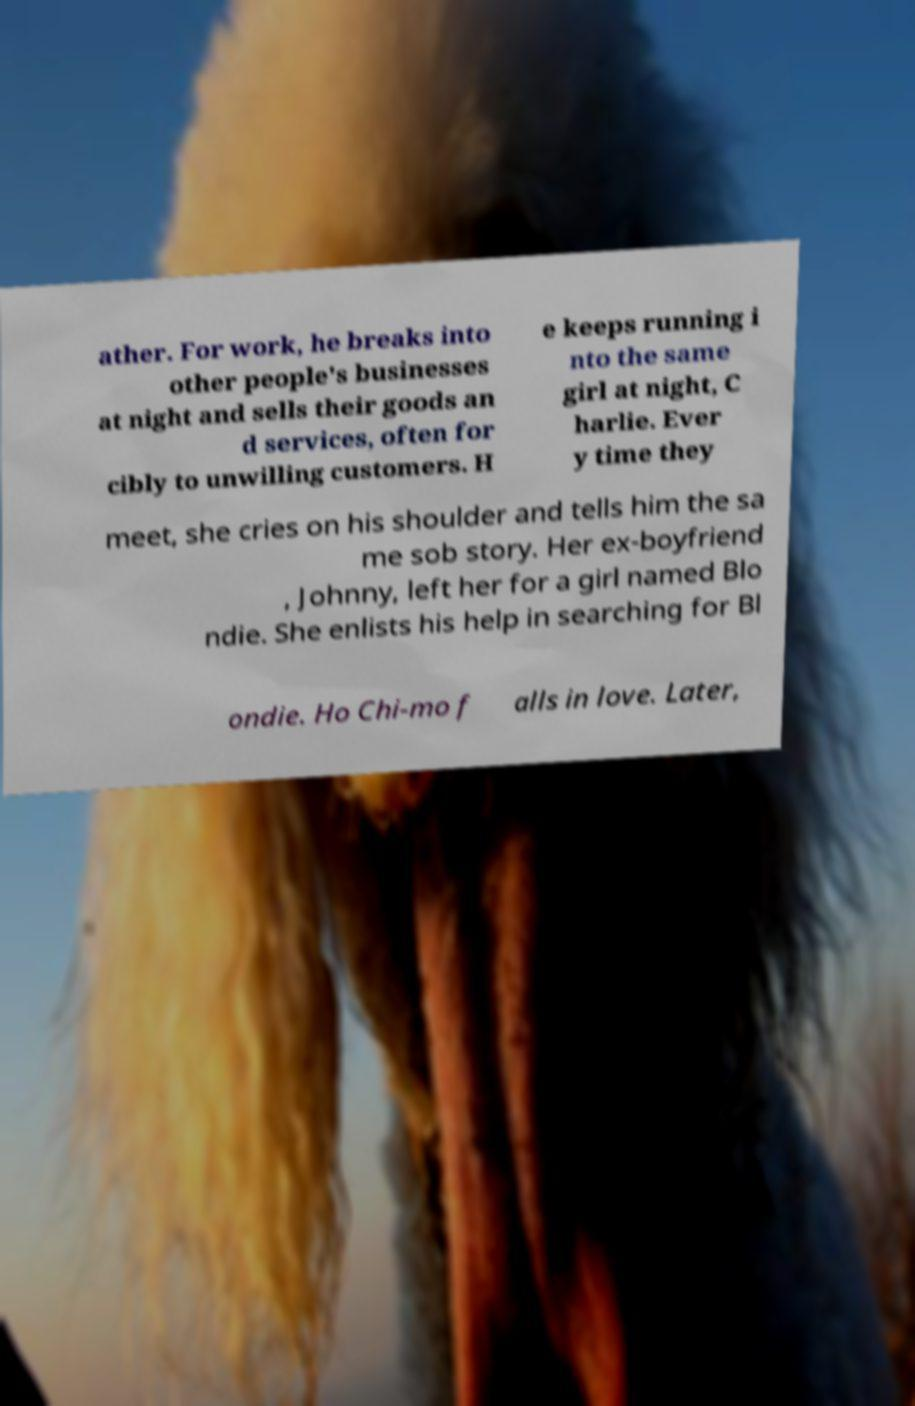There's text embedded in this image that I need extracted. Can you transcribe it verbatim? ather. For work, he breaks into other people's businesses at night and sells their goods an d services, often for cibly to unwilling customers. H e keeps running i nto the same girl at night, C harlie. Ever y time they meet, she cries on his shoulder and tells him the sa me sob story. Her ex-boyfriend , Johnny, left her for a girl named Blo ndie. She enlists his help in searching for Bl ondie. Ho Chi-mo f alls in love. Later, 